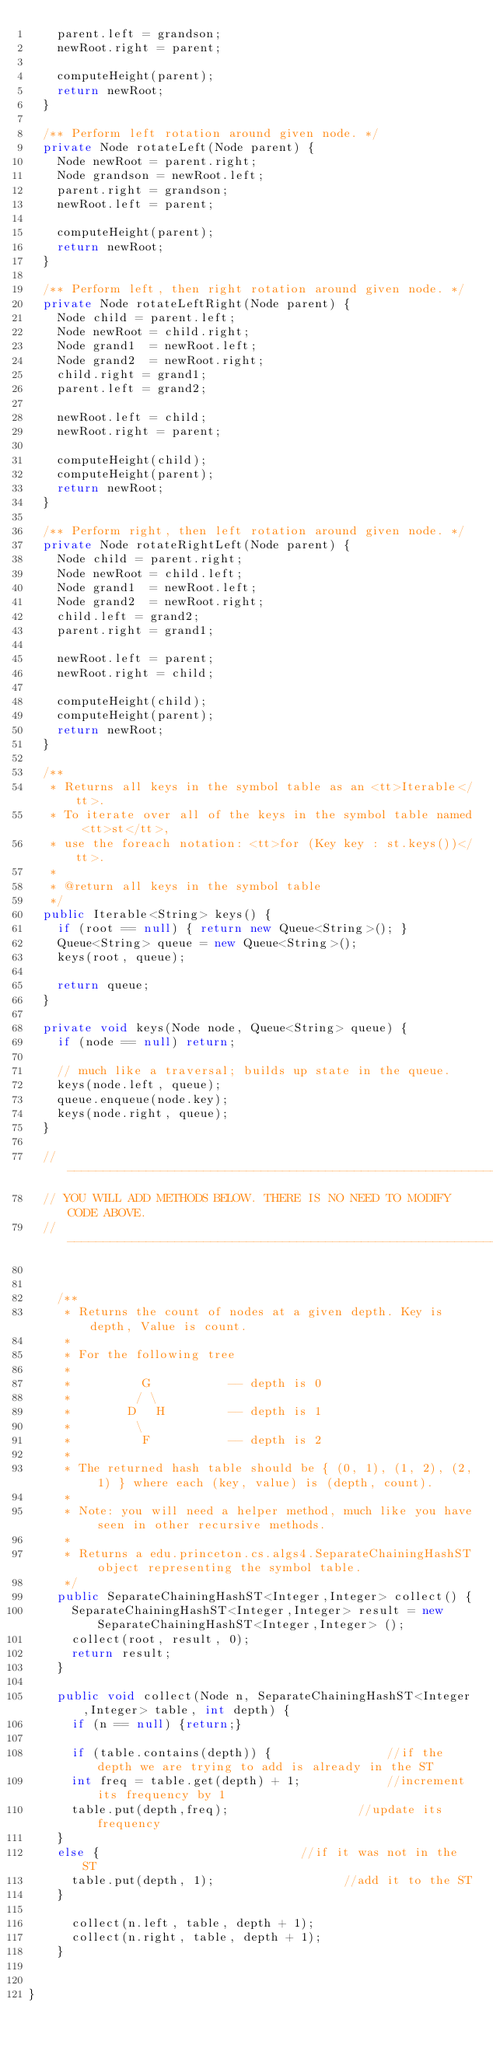Convert code to text. <code><loc_0><loc_0><loc_500><loc_500><_Java_>		parent.left = grandson;
		newRoot.right = parent;

		computeHeight(parent);
		return newRoot;
	}

	/** Perform left rotation around given node. */
	private Node rotateLeft(Node parent) {
		Node newRoot = parent.right;
		Node grandson = newRoot.left;
		parent.right = grandson;
		newRoot.left = parent;

		computeHeight(parent);
		return newRoot;
	}

	/** Perform left, then right rotation around given node. */
	private Node rotateLeftRight(Node parent) {
		Node child = parent.left;
		Node newRoot = child.right;
		Node grand1  = newRoot.left;
		Node grand2  = newRoot.right;
		child.right = grand1;
		parent.left = grand2;

		newRoot.left = child;
		newRoot.right = parent;

		computeHeight(child);
		computeHeight(parent);
		return newRoot;
	}

	/** Perform right, then left rotation around given node. */
	private Node rotateRightLeft(Node parent) {
		Node child = parent.right;
		Node newRoot = child.left;
		Node grand1  = newRoot.left;
		Node grand2  = newRoot.right;
		child.left = grand2;
		parent.right = grand1;

		newRoot.left = parent;
		newRoot.right = child;

		computeHeight(child);
		computeHeight(parent);
		return newRoot;
	}
	
	/**
	 * Returns all keys in the symbol table as an <tt>Iterable</tt>.
	 * To iterate over all of the keys in the symbol table named <tt>st</tt>,
	 * use the foreach notation: <tt>for (Key key : st.keys())</tt>.
	 *
	 * @return all keys in the symbol table
	 */
	public Iterable<String> keys() {
		if (root == null) { return new Queue<String>(); }
		Queue<String> queue = new Queue<String>();
		keys(root, queue);
		
		return queue;
	}

	private void keys(Node node, Queue<String> queue) { 
		if (node == null) return; 
		
		// much like a traversal; builds up state in the queue.
		keys(node.left, queue); 
		queue.enqueue(node.key); 
		keys(node.right, queue);
	}
	
	// ------------------------------------------------------------------------------------------------
	// YOU WILL ADD METHODS BELOW. THERE IS NO NEED TO MODIFY CODE ABOVE.
	// ------------------------------------------------------------------------------------------------
	

    /** 
     * Returns the count of nodes at a given depth. Key is depth, Value is count.
     * 
     * For the following tree
     * 
     *          G           -- depth is 0
     *         / \
     *        D   H         -- depth is 1
     *         \
     *          F           -- depth is 2
     *  
     * The returned hash table should be { (0, 1), (1, 2), (2, 1) } where each (key, value) is (depth, count).
     * 
     * Note: you will need a helper method, much like you have seen in other recursive methods.
     * 
     * Returns a edu.princeton.cs.algs4.SeparateChainingHashST object representing the symbol table.
     */
    public SeparateChainingHashST<Integer,Integer> collect() {
    	SeparateChainingHashST<Integer,Integer> result = new SeparateChainingHashST<Integer,Integer> ();	
    	collect(root, result, 0);
    	return result;
    }
    
    public void collect(Node n, SeparateChainingHashST<Integer,Integer> table, int depth) {
    	if (n == null) {return;}
    	
    	if (table.contains(depth)) {								//if the depth we are trying to add is already in the ST
			int freq = table.get(depth) + 1;						//increment its frequency by 1
			table.put(depth,freq);									//update its frequency
		}
		else {														//if it was not in the ST
			table.put(depth, 1);									//add it to the ST
		}
    	
    	collect(n.left, table, depth + 1);
    	collect(n.right, table, depth + 1);
    }
    	
    
}
</code> 